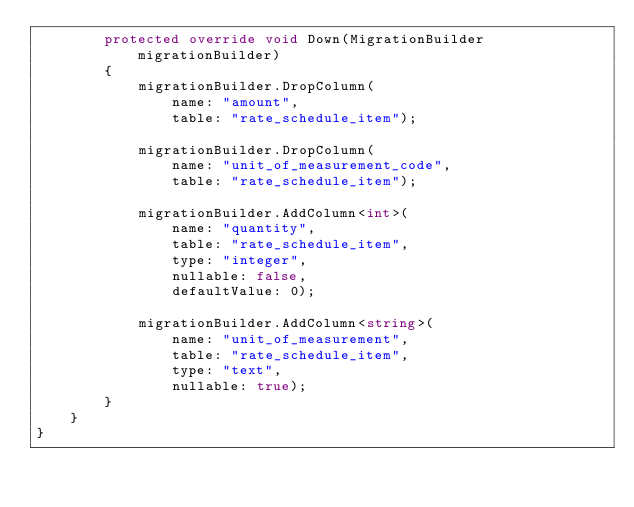Convert code to text. <code><loc_0><loc_0><loc_500><loc_500><_C#_>        protected override void Down(MigrationBuilder migrationBuilder)
        {
            migrationBuilder.DropColumn(
                name: "amount",
                table: "rate_schedule_item");

            migrationBuilder.DropColumn(
                name: "unit_of_measurement_code",
                table: "rate_schedule_item");

            migrationBuilder.AddColumn<int>(
                name: "quantity",
                table: "rate_schedule_item",
                type: "integer",
                nullable: false,
                defaultValue: 0);

            migrationBuilder.AddColumn<string>(
                name: "unit_of_measurement",
                table: "rate_schedule_item",
                type: "text",
                nullable: true);
        }
    }
}
</code> 